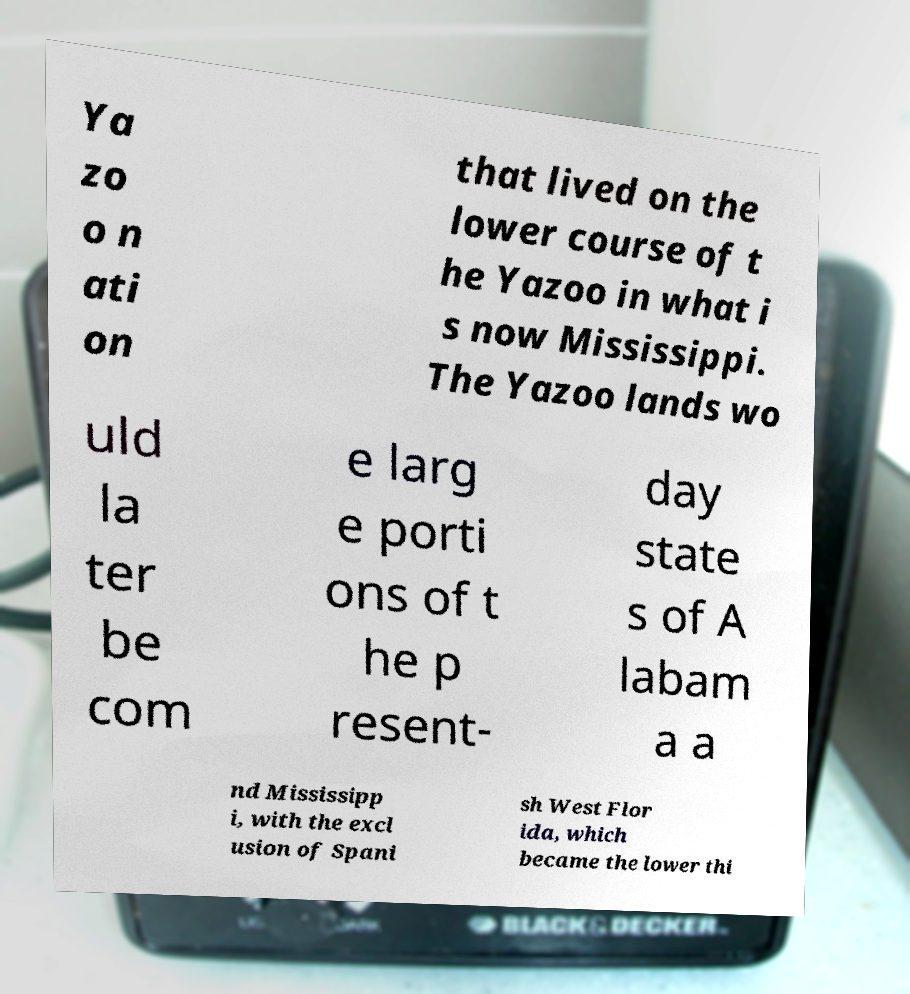Please identify and transcribe the text found in this image. Ya zo o n ati on that lived on the lower course of t he Yazoo in what i s now Mississippi. The Yazoo lands wo uld la ter be com e larg e porti ons of t he p resent- day state s of A labam a a nd Mississipp i, with the excl usion of Spani sh West Flor ida, which became the lower thi 